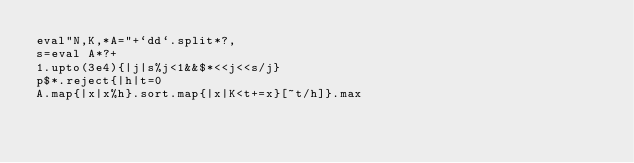Convert code to text. <code><loc_0><loc_0><loc_500><loc_500><_Ruby_>eval"N,K,*A="+`dd`.split*?,
s=eval A*?+
1.upto(3e4){|j|s%j<1&&$*<<j<<s/j}
p$*.reject{|h|t=0
A.map{|x|x%h}.sort.map{|x|K<t+=x}[~t/h]}.max</code> 